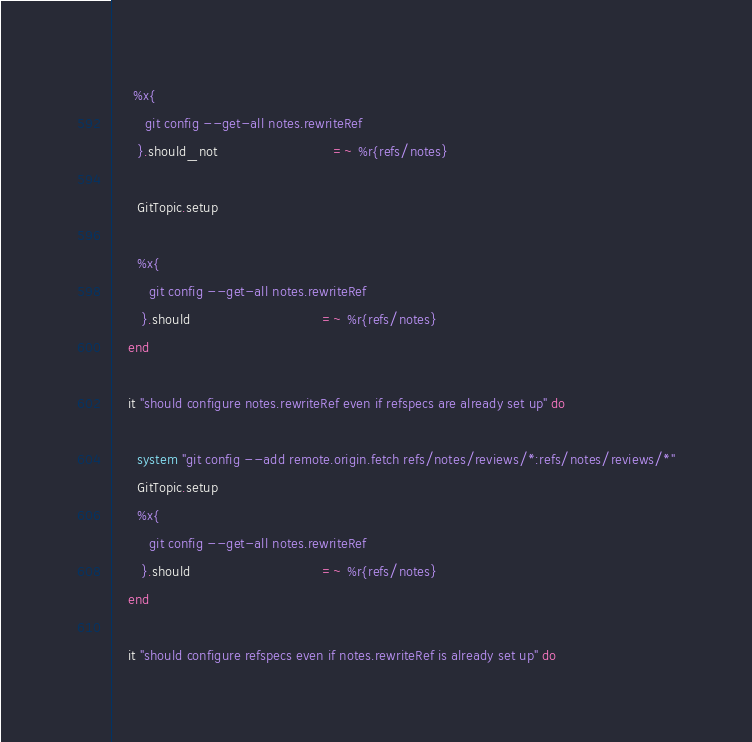Convert code to text. <code><loc_0><loc_0><loc_500><loc_500><_Ruby_>
     %x{ 
        git config --get-all notes.rewriteRef
      }.should_not                            =~ %r{refs/notes}

      GitTopic.setup

      %x{ 
         git config --get-all notes.rewriteRef
       }.should                                =~ %r{refs/notes}
    end

    it "should configure notes.rewriteRef even if refspecs are already set up" do

      system "git config --add remote.origin.fetch refs/notes/reviews/*:refs/notes/reviews/*"
      GitTopic.setup
      %x{ 
         git config --get-all notes.rewriteRef
       }.should                                =~ %r{refs/notes}
    end

    it "should configure refspecs even if notes.rewriteRef is already set up" do</code> 